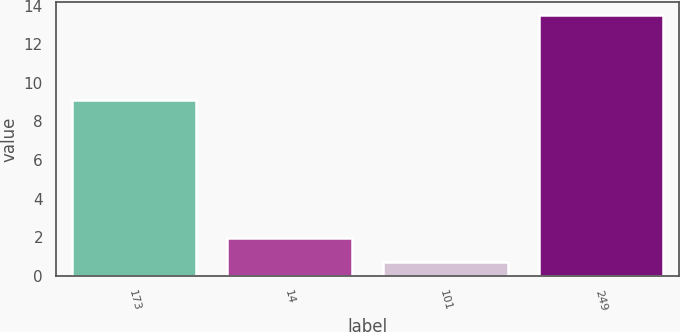Convert chart to OTSL. <chart><loc_0><loc_0><loc_500><loc_500><bar_chart><fcel>173<fcel>14<fcel>101<fcel>249<nl><fcel>9.1<fcel>1.98<fcel>0.7<fcel>13.5<nl></chart> 